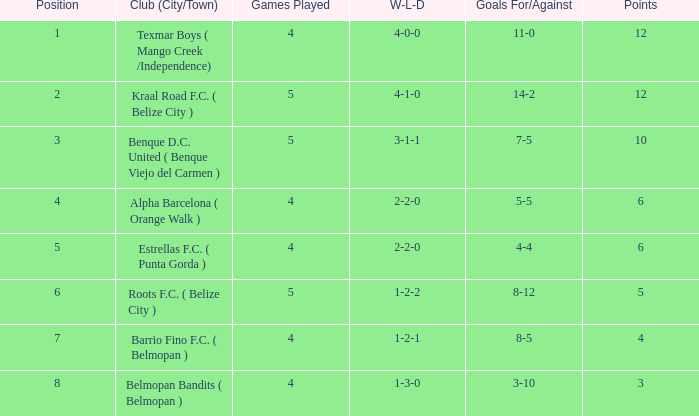Help me parse the entirety of this table. {'header': ['Position', 'Club (City/Town)', 'Games Played', 'W-L-D', 'Goals For/Against', 'Points'], 'rows': [['1', 'Texmar Boys ( Mango Creek /Independence)', '4', '4-0-0', '11-0', '12'], ['2', 'Kraal Road F.C. ( Belize City )', '5', '4-1-0', '14-2', '12'], ['3', 'Benque D.C. United ( Benque Viejo del Carmen )', '5', '3-1-1', '7-5', '10'], ['4', 'Alpha Barcelona ( Orange Walk )', '4', '2-2-0', '5-5', '6'], ['5', 'Estrellas F.C. ( Punta Gorda )', '4', '2-2-0', '4-4', '6'], ['6', 'Roots F.C. ( Belize City )', '5', '1-2-2', '8-12', '5'], ['7', 'Barrio Fino F.C. ( Belmopan )', '4', '1-2-1', '8-5', '4'], ['8', 'Belmopan Bandits ( Belmopan )', '4', '1-3-0', '3-10', '3']]} What's the w-l-d condition with the placement being 1? 4-0-0. 